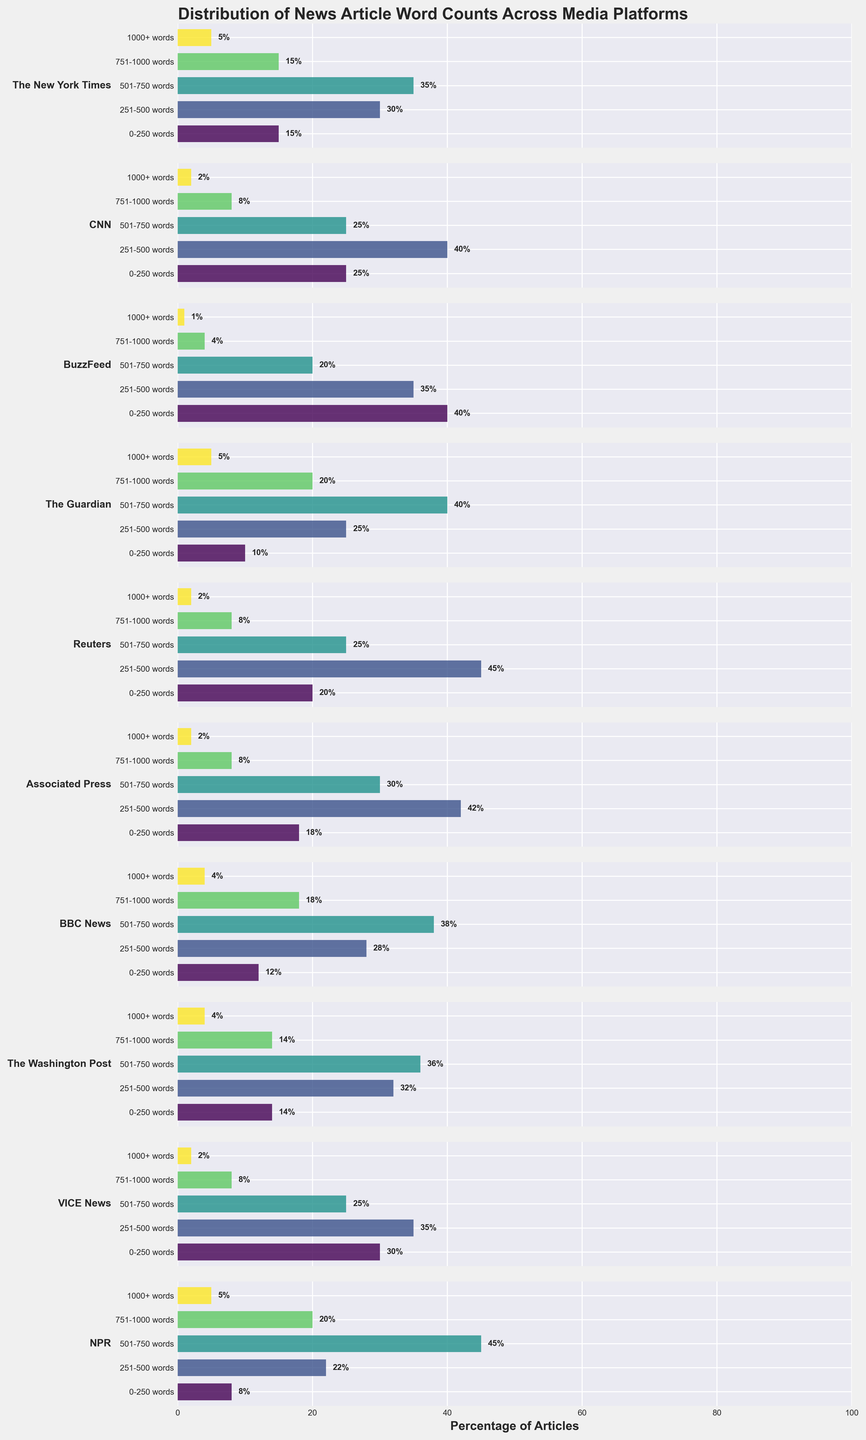What is the title of the figure? The title is located at the top of the figure in bold and large font. It reads "Distribution of News Article Word Counts Across Media Platforms".
Answer: Distribution of News Article Word Counts Across Media Platforms How many categories of word count are represented in the figure? The horizontal subplots represent categories defined by ranges of word counts. These categories are "0-250 words", "251-500 words", "501-750 words", "751-1000 words", and "1000+ words".
Answer: 5 Which media platform has the highest percentage of articles in the "0-250 words" category? By looking at the horizontal bars for the "0-250 words" category, BuzzFeed has the highest percentage at 40%.
Answer: BuzzFeed What percentage of CNN's articles are in the "251-500 words" category? Refer to the bar corresponding to CNN and the "251-500 words" category. The value written next to the bar is 40%.
Answer: 40% How does the distribution of articles in "The Guardian" compare between "501-750 words" and "1000+ words" categories? For "The Guardian", compare the horizontal bars for the respective categories. The "501-750 words" bar (40%) is significantly longer than the "1000+ words" bar (5%).
Answer: "501-750 words" is much higher than "1000+ words" Which two media platforms have the same percentage of articles in the "751-1000 words" category and what is that percentage? Look at the bars for the "751-1000 words" category and identify the platforms with equal lengths. Both Reuters and Associated Press have 8% of articles in this category.
Answer: Reuters and Associated Press, 8% For NPR, what is the combined percentage of articles in the "501-750 words" and "751-1000 words" categories? Sum the percentages for NPR in these two categories: "501-750 words" (45%) + "751-1000 words" (20%). The combined percentage is 65%.
Answer: 65% Which platform has the most even distribution of articles across all categories? By observing the relative lengths of the bars for each platform, VICE News shows a relatively even distribution, with percentages closer in value across all categories.
Answer: VICE News What is the primary visual difference between "The Washington Post" and "BBC News" in their article distribution? Look at the distribution of word count categories for both platforms. "The Washington Post" has a slightly higher proportion in "251-500 words" and "501-750 words" categories compared to "BBC News", with less in the "751-1000 words" category.
Answer: "The Washington Post" has more articles in the "251-500 words" and "501-750 words" categories than "BBC News" How does the total percentage of articles with more than 750 words compare between The New York Times and BuzzFeed? Sum the percentages for categories "751-1000 words" and "1000+ words" for both platforms. The New York Times: 15% (751-1000 words) + 5% (1000+ words) = 20%. BuzzFeed: 4% (751-1000 words) + 1% (1000+ words) = 5%.
Answer: The New York Times has a higher total percentage (20%) compared to BuzzFeed (5%) 